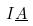Convert formula to latex. <formula><loc_0><loc_0><loc_500><loc_500>I \underline { A }</formula> 